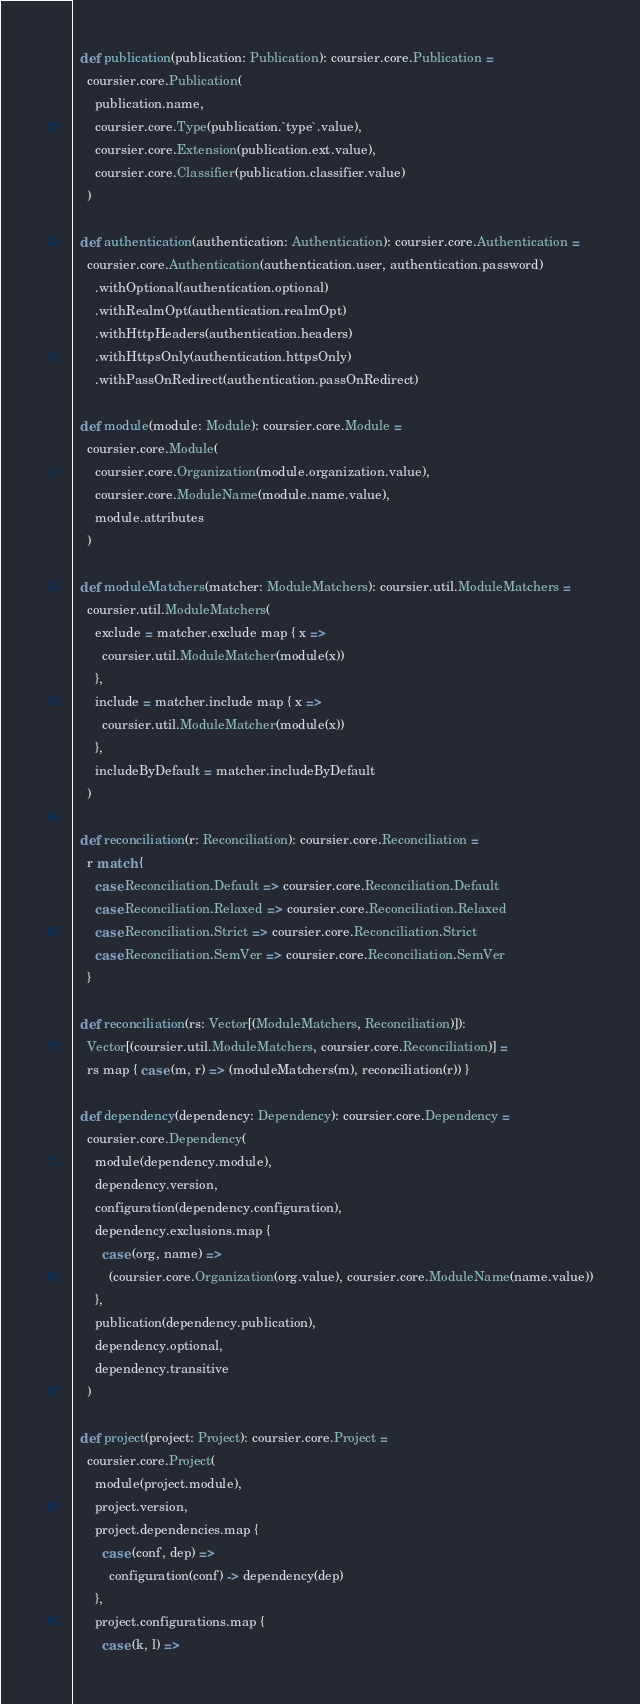<code> <loc_0><loc_0><loc_500><loc_500><_Scala_>
  def publication(publication: Publication): coursier.core.Publication =
    coursier.core.Publication(
      publication.name,
      coursier.core.Type(publication.`type`.value),
      coursier.core.Extension(publication.ext.value),
      coursier.core.Classifier(publication.classifier.value)
    )

  def authentication(authentication: Authentication): coursier.core.Authentication =
    coursier.core.Authentication(authentication.user, authentication.password)
      .withOptional(authentication.optional)
      .withRealmOpt(authentication.realmOpt)
      .withHttpHeaders(authentication.headers)
      .withHttpsOnly(authentication.httpsOnly)
      .withPassOnRedirect(authentication.passOnRedirect)

  def module(module: Module): coursier.core.Module =
    coursier.core.Module(
      coursier.core.Organization(module.organization.value),
      coursier.core.ModuleName(module.name.value),
      module.attributes
    )

  def moduleMatchers(matcher: ModuleMatchers): coursier.util.ModuleMatchers =
    coursier.util.ModuleMatchers(
      exclude = matcher.exclude map { x =>
        coursier.util.ModuleMatcher(module(x))
      },
      include = matcher.include map { x =>
        coursier.util.ModuleMatcher(module(x))
      },
      includeByDefault = matcher.includeByDefault
    )

  def reconciliation(r: Reconciliation): coursier.core.Reconciliation =
    r match {
      case Reconciliation.Default => coursier.core.Reconciliation.Default
      case Reconciliation.Relaxed => coursier.core.Reconciliation.Relaxed
      case Reconciliation.Strict => coursier.core.Reconciliation.Strict
      case Reconciliation.SemVer => coursier.core.Reconciliation.SemVer
    }

  def reconciliation(rs: Vector[(ModuleMatchers, Reconciliation)]):
    Vector[(coursier.util.ModuleMatchers, coursier.core.Reconciliation)] =
    rs map { case (m, r) => (moduleMatchers(m), reconciliation(r)) }

  def dependency(dependency: Dependency): coursier.core.Dependency =
    coursier.core.Dependency(
      module(dependency.module),
      dependency.version,
      configuration(dependency.configuration),
      dependency.exclusions.map {
        case (org, name) =>
          (coursier.core.Organization(org.value), coursier.core.ModuleName(name.value))
      },
      publication(dependency.publication),
      dependency.optional,
      dependency.transitive
    )

  def project(project: Project): coursier.core.Project =
    coursier.core.Project(
      module(project.module),
      project.version,
      project.dependencies.map {
        case (conf, dep) =>
          configuration(conf) -> dependency(dep)
      },
      project.configurations.map {
        case (k, l) =></code> 